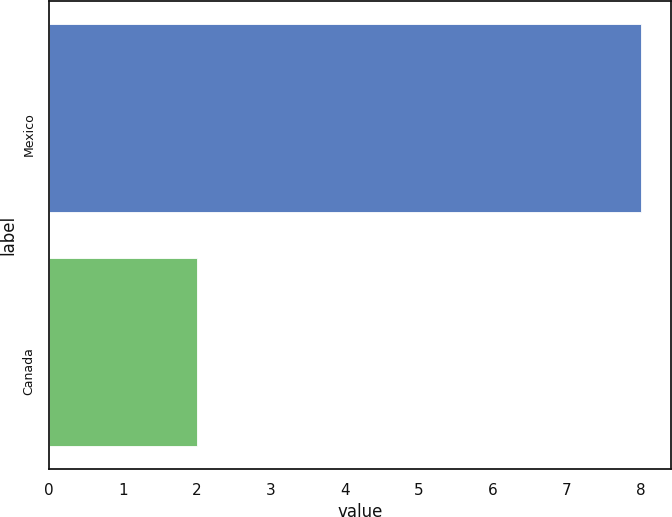<chart> <loc_0><loc_0><loc_500><loc_500><bar_chart><fcel>Mexico<fcel>Canada<nl><fcel>8<fcel>2<nl></chart> 